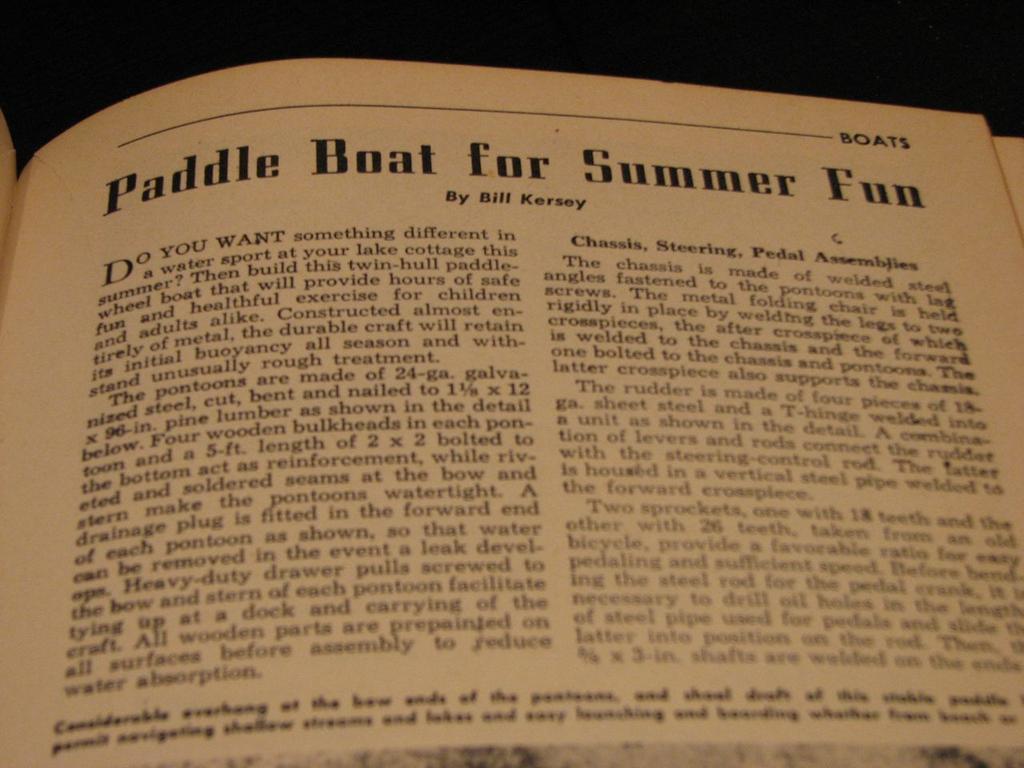What is the title of the article?
Ensure brevity in your answer.  Paddle boat for summer fun. 